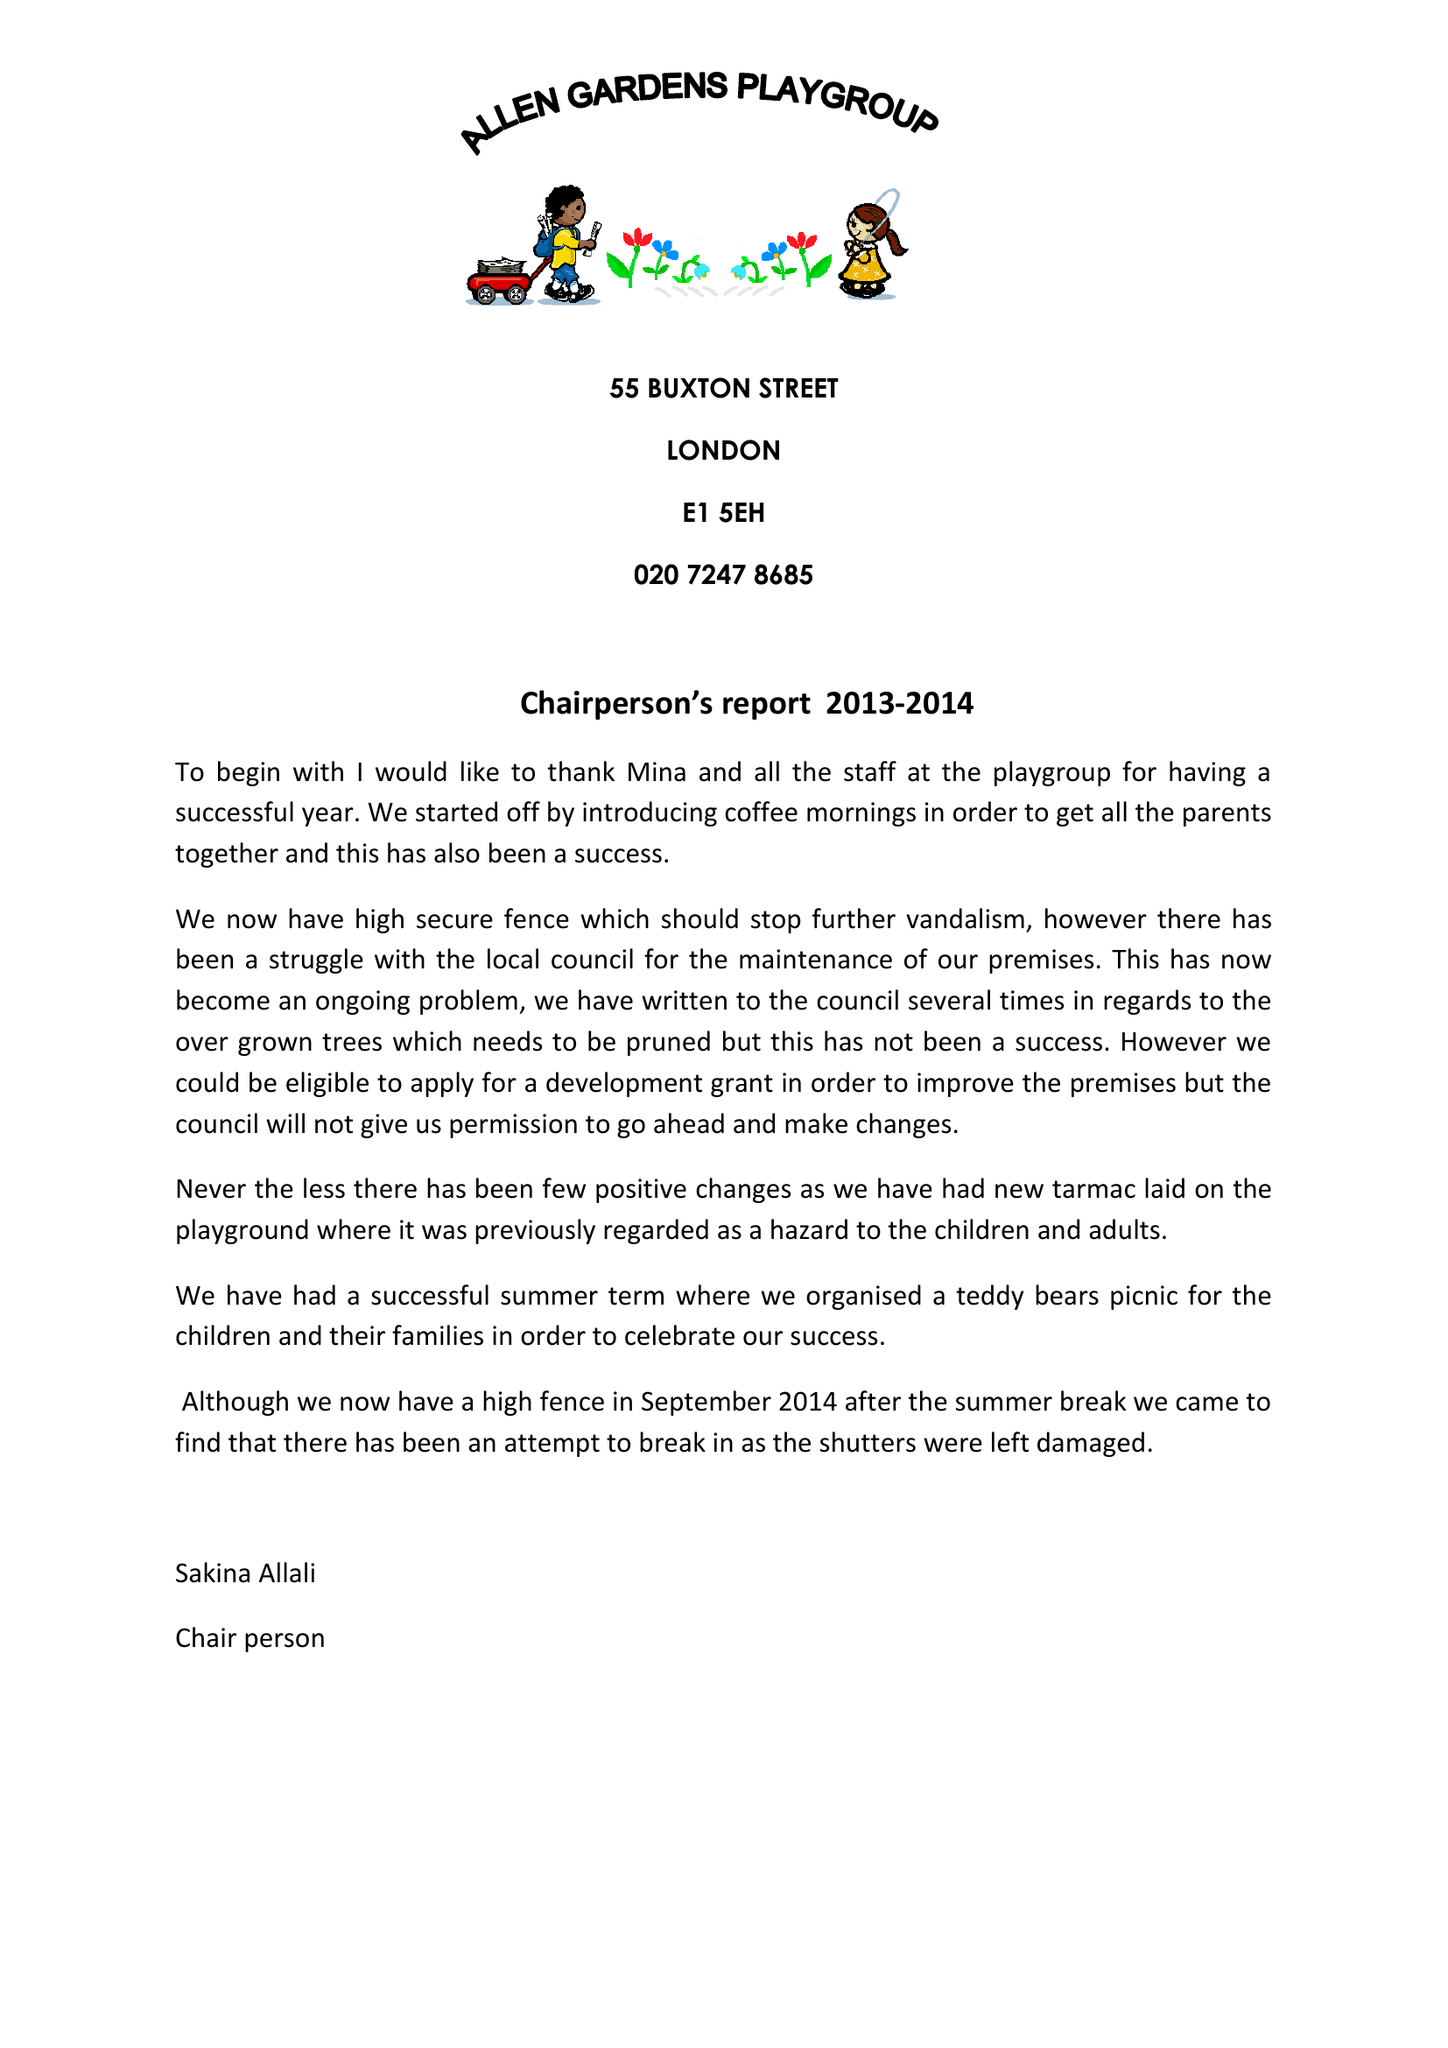What is the value for the spending_annually_in_british_pounds?
Answer the question using a single word or phrase. 157106.00 